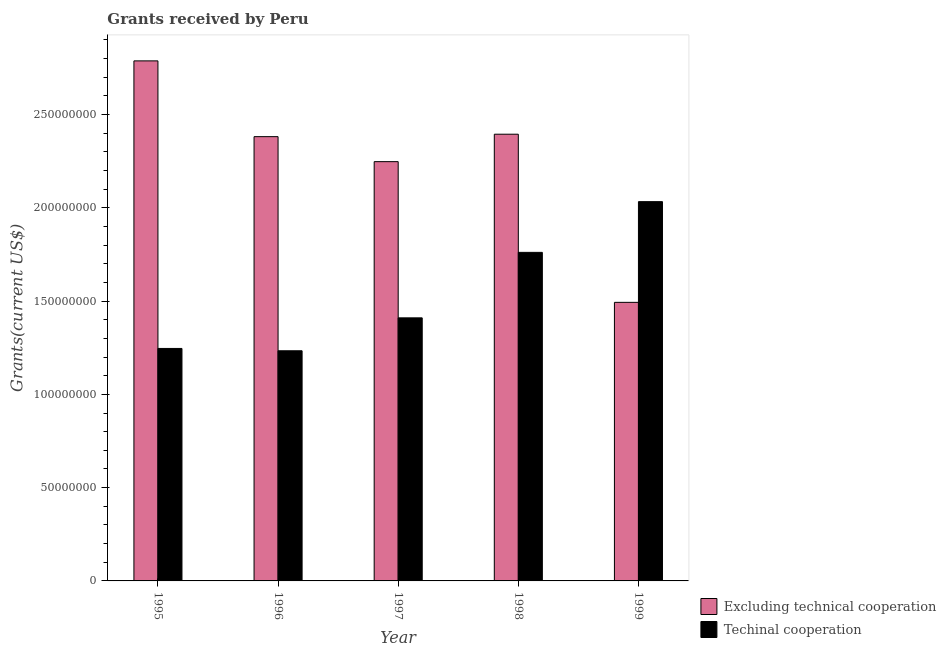How many different coloured bars are there?
Make the answer very short. 2. How many groups of bars are there?
Your answer should be compact. 5. What is the label of the 4th group of bars from the left?
Your answer should be compact. 1998. In how many cases, is the number of bars for a given year not equal to the number of legend labels?
Offer a terse response. 0. What is the amount of grants received(excluding technical cooperation) in 1996?
Offer a very short reply. 2.38e+08. Across all years, what is the maximum amount of grants received(including technical cooperation)?
Provide a succinct answer. 2.03e+08. Across all years, what is the minimum amount of grants received(excluding technical cooperation)?
Your answer should be very brief. 1.49e+08. What is the total amount of grants received(including technical cooperation) in the graph?
Provide a succinct answer. 7.68e+08. What is the difference between the amount of grants received(excluding technical cooperation) in 1995 and that in 1997?
Provide a short and direct response. 5.40e+07. What is the difference between the amount of grants received(including technical cooperation) in 1997 and the amount of grants received(excluding technical cooperation) in 1998?
Keep it short and to the point. -3.51e+07. What is the average amount of grants received(including technical cooperation) per year?
Your response must be concise. 1.54e+08. In the year 1997, what is the difference between the amount of grants received(including technical cooperation) and amount of grants received(excluding technical cooperation)?
Your answer should be very brief. 0. In how many years, is the amount of grants received(including technical cooperation) greater than 160000000 US$?
Your answer should be compact. 2. What is the ratio of the amount of grants received(excluding technical cooperation) in 1995 to that in 1998?
Give a very brief answer. 1.16. Is the amount of grants received(excluding technical cooperation) in 1995 less than that in 1996?
Provide a short and direct response. No. What is the difference between the highest and the second highest amount of grants received(including technical cooperation)?
Give a very brief answer. 2.72e+07. What is the difference between the highest and the lowest amount of grants received(including technical cooperation)?
Offer a terse response. 7.99e+07. In how many years, is the amount of grants received(excluding technical cooperation) greater than the average amount of grants received(excluding technical cooperation) taken over all years?
Provide a short and direct response. 3. What does the 2nd bar from the left in 1999 represents?
Keep it short and to the point. Techinal cooperation. What does the 2nd bar from the right in 1998 represents?
Your response must be concise. Excluding technical cooperation. How many bars are there?
Your answer should be very brief. 10. How many years are there in the graph?
Make the answer very short. 5. Does the graph contain grids?
Give a very brief answer. No. How many legend labels are there?
Provide a short and direct response. 2. What is the title of the graph?
Provide a succinct answer. Grants received by Peru. Does "Taxes on exports" appear as one of the legend labels in the graph?
Provide a short and direct response. No. What is the label or title of the X-axis?
Your response must be concise. Year. What is the label or title of the Y-axis?
Provide a succinct answer. Grants(current US$). What is the Grants(current US$) of Excluding technical cooperation in 1995?
Offer a very short reply. 2.79e+08. What is the Grants(current US$) of Techinal cooperation in 1995?
Offer a very short reply. 1.25e+08. What is the Grants(current US$) in Excluding technical cooperation in 1996?
Give a very brief answer. 2.38e+08. What is the Grants(current US$) in Techinal cooperation in 1996?
Your answer should be compact. 1.23e+08. What is the Grants(current US$) of Excluding technical cooperation in 1997?
Your response must be concise. 2.25e+08. What is the Grants(current US$) in Techinal cooperation in 1997?
Your response must be concise. 1.41e+08. What is the Grants(current US$) in Excluding technical cooperation in 1998?
Ensure brevity in your answer.  2.39e+08. What is the Grants(current US$) of Techinal cooperation in 1998?
Your response must be concise. 1.76e+08. What is the Grants(current US$) of Excluding technical cooperation in 1999?
Give a very brief answer. 1.49e+08. What is the Grants(current US$) of Techinal cooperation in 1999?
Provide a succinct answer. 2.03e+08. Across all years, what is the maximum Grants(current US$) in Excluding technical cooperation?
Provide a short and direct response. 2.79e+08. Across all years, what is the maximum Grants(current US$) of Techinal cooperation?
Your response must be concise. 2.03e+08. Across all years, what is the minimum Grants(current US$) of Excluding technical cooperation?
Your answer should be very brief. 1.49e+08. Across all years, what is the minimum Grants(current US$) of Techinal cooperation?
Your response must be concise. 1.23e+08. What is the total Grants(current US$) in Excluding technical cooperation in the graph?
Your answer should be very brief. 1.13e+09. What is the total Grants(current US$) in Techinal cooperation in the graph?
Keep it short and to the point. 7.68e+08. What is the difference between the Grants(current US$) of Excluding technical cooperation in 1995 and that in 1996?
Keep it short and to the point. 4.06e+07. What is the difference between the Grants(current US$) of Techinal cooperation in 1995 and that in 1996?
Your response must be concise. 1.25e+06. What is the difference between the Grants(current US$) of Excluding technical cooperation in 1995 and that in 1997?
Ensure brevity in your answer.  5.40e+07. What is the difference between the Grants(current US$) in Techinal cooperation in 1995 and that in 1997?
Your answer should be very brief. -1.64e+07. What is the difference between the Grants(current US$) in Excluding technical cooperation in 1995 and that in 1998?
Provide a short and direct response. 3.93e+07. What is the difference between the Grants(current US$) of Techinal cooperation in 1995 and that in 1998?
Your answer should be very brief. -5.15e+07. What is the difference between the Grants(current US$) of Excluding technical cooperation in 1995 and that in 1999?
Provide a succinct answer. 1.29e+08. What is the difference between the Grants(current US$) of Techinal cooperation in 1995 and that in 1999?
Offer a terse response. -7.87e+07. What is the difference between the Grants(current US$) of Excluding technical cooperation in 1996 and that in 1997?
Your response must be concise. 1.34e+07. What is the difference between the Grants(current US$) in Techinal cooperation in 1996 and that in 1997?
Ensure brevity in your answer.  -1.76e+07. What is the difference between the Grants(current US$) in Excluding technical cooperation in 1996 and that in 1998?
Your answer should be very brief. -1.31e+06. What is the difference between the Grants(current US$) in Techinal cooperation in 1996 and that in 1998?
Give a very brief answer. -5.28e+07. What is the difference between the Grants(current US$) in Excluding technical cooperation in 1996 and that in 1999?
Give a very brief answer. 8.88e+07. What is the difference between the Grants(current US$) in Techinal cooperation in 1996 and that in 1999?
Your answer should be compact. -7.99e+07. What is the difference between the Grants(current US$) in Excluding technical cooperation in 1997 and that in 1998?
Offer a very short reply. -1.47e+07. What is the difference between the Grants(current US$) of Techinal cooperation in 1997 and that in 1998?
Offer a very short reply. -3.51e+07. What is the difference between the Grants(current US$) of Excluding technical cooperation in 1997 and that in 1999?
Keep it short and to the point. 7.54e+07. What is the difference between the Grants(current US$) in Techinal cooperation in 1997 and that in 1999?
Make the answer very short. -6.23e+07. What is the difference between the Grants(current US$) in Excluding technical cooperation in 1998 and that in 1999?
Provide a short and direct response. 9.01e+07. What is the difference between the Grants(current US$) in Techinal cooperation in 1998 and that in 1999?
Provide a succinct answer. -2.72e+07. What is the difference between the Grants(current US$) in Excluding technical cooperation in 1995 and the Grants(current US$) in Techinal cooperation in 1996?
Ensure brevity in your answer.  1.55e+08. What is the difference between the Grants(current US$) in Excluding technical cooperation in 1995 and the Grants(current US$) in Techinal cooperation in 1997?
Ensure brevity in your answer.  1.38e+08. What is the difference between the Grants(current US$) of Excluding technical cooperation in 1995 and the Grants(current US$) of Techinal cooperation in 1998?
Make the answer very short. 1.03e+08. What is the difference between the Grants(current US$) in Excluding technical cooperation in 1995 and the Grants(current US$) in Techinal cooperation in 1999?
Provide a short and direct response. 7.55e+07. What is the difference between the Grants(current US$) in Excluding technical cooperation in 1996 and the Grants(current US$) in Techinal cooperation in 1997?
Provide a short and direct response. 9.71e+07. What is the difference between the Grants(current US$) of Excluding technical cooperation in 1996 and the Grants(current US$) of Techinal cooperation in 1998?
Offer a terse response. 6.20e+07. What is the difference between the Grants(current US$) in Excluding technical cooperation in 1996 and the Grants(current US$) in Techinal cooperation in 1999?
Provide a short and direct response. 3.48e+07. What is the difference between the Grants(current US$) in Excluding technical cooperation in 1997 and the Grants(current US$) in Techinal cooperation in 1998?
Your answer should be very brief. 4.86e+07. What is the difference between the Grants(current US$) in Excluding technical cooperation in 1997 and the Grants(current US$) in Techinal cooperation in 1999?
Make the answer very short. 2.14e+07. What is the difference between the Grants(current US$) of Excluding technical cooperation in 1998 and the Grants(current US$) of Techinal cooperation in 1999?
Ensure brevity in your answer.  3.62e+07. What is the average Grants(current US$) in Excluding technical cooperation per year?
Keep it short and to the point. 2.26e+08. What is the average Grants(current US$) in Techinal cooperation per year?
Your response must be concise. 1.54e+08. In the year 1995, what is the difference between the Grants(current US$) of Excluding technical cooperation and Grants(current US$) of Techinal cooperation?
Give a very brief answer. 1.54e+08. In the year 1996, what is the difference between the Grants(current US$) in Excluding technical cooperation and Grants(current US$) in Techinal cooperation?
Provide a succinct answer. 1.15e+08. In the year 1997, what is the difference between the Grants(current US$) in Excluding technical cooperation and Grants(current US$) in Techinal cooperation?
Your answer should be compact. 8.37e+07. In the year 1998, what is the difference between the Grants(current US$) of Excluding technical cooperation and Grants(current US$) of Techinal cooperation?
Provide a succinct answer. 6.33e+07. In the year 1999, what is the difference between the Grants(current US$) in Excluding technical cooperation and Grants(current US$) in Techinal cooperation?
Provide a succinct answer. -5.40e+07. What is the ratio of the Grants(current US$) in Excluding technical cooperation in 1995 to that in 1996?
Provide a short and direct response. 1.17. What is the ratio of the Grants(current US$) in Techinal cooperation in 1995 to that in 1996?
Give a very brief answer. 1.01. What is the ratio of the Grants(current US$) of Excluding technical cooperation in 1995 to that in 1997?
Provide a short and direct response. 1.24. What is the ratio of the Grants(current US$) of Techinal cooperation in 1995 to that in 1997?
Provide a short and direct response. 0.88. What is the ratio of the Grants(current US$) of Excluding technical cooperation in 1995 to that in 1998?
Provide a succinct answer. 1.16. What is the ratio of the Grants(current US$) in Techinal cooperation in 1995 to that in 1998?
Your answer should be very brief. 0.71. What is the ratio of the Grants(current US$) in Excluding technical cooperation in 1995 to that in 1999?
Keep it short and to the point. 1.87. What is the ratio of the Grants(current US$) of Techinal cooperation in 1995 to that in 1999?
Give a very brief answer. 0.61. What is the ratio of the Grants(current US$) of Excluding technical cooperation in 1996 to that in 1997?
Give a very brief answer. 1.06. What is the ratio of the Grants(current US$) of Techinal cooperation in 1996 to that in 1997?
Offer a very short reply. 0.87. What is the ratio of the Grants(current US$) in Excluding technical cooperation in 1996 to that in 1998?
Ensure brevity in your answer.  0.99. What is the ratio of the Grants(current US$) of Techinal cooperation in 1996 to that in 1998?
Ensure brevity in your answer.  0.7. What is the ratio of the Grants(current US$) of Excluding technical cooperation in 1996 to that in 1999?
Offer a very short reply. 1.59. What is the ratio of the Grants(current US$) in Techinal cooperation in 1996 to that in 1999?
Your answer should be compact. 0.61. What is the ratio of the Grants(current US$) in Excluding technical cooperation in 1997 to that in 1998?
Your answer should be compact. 0.94. What is the ratio of the Grants(current US$) in Techinal cooperation in 1997 to that in 1998?
Your response must be concise. 0.8. What is the ratio of the Grants(current US$) in Excluding technical cooperation in 1997 to that in 1999?
Ensure brevity in your answer.  1.51. What is the ratio of the Grants(current US$) of Techinal cooperation in 1997 to that in 1999?
Ensure brevity in your answer.  0.69. What is the ratio of the Grants(current US$) in Excluding technical cooperation in 1998 to that in 1999?
Keep it short and to the point. 1.6. What is the ratio of the Grants(current US$) of Techinal cooperation in 1998 to that in 1999?
Your answer should be compact. 0.87. What is the difference between the highest and the second highest Grants(current US$) in Excluding technical cooperation?
Offer a very short reply. 3.93e+07. What is the difference between the highest and the second highest Grants(current US$) of Techinal cooperation?
Ensure brevity in your answer.  2.72e+07. What is the difference between the highest and the lowest Grants(current US$) in Excluding technical cooperation?
Make the answer very short. 1.29e+08. What is the difference between the highest and the lowest Grants(current US$) of Techinal cooperation?
Provide a succinct answer. 7.99e+07. 